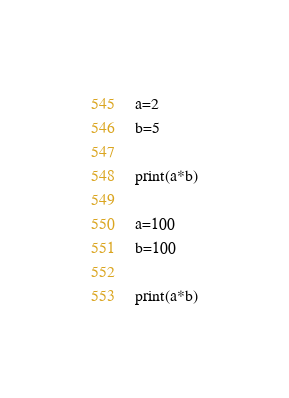Convert code to text. <code><loc_0><loc_0><loc_500><loc_500><_Python_>a=2
b=5

print(a*b)

a=100
b=100

print(a*b)
</code> 